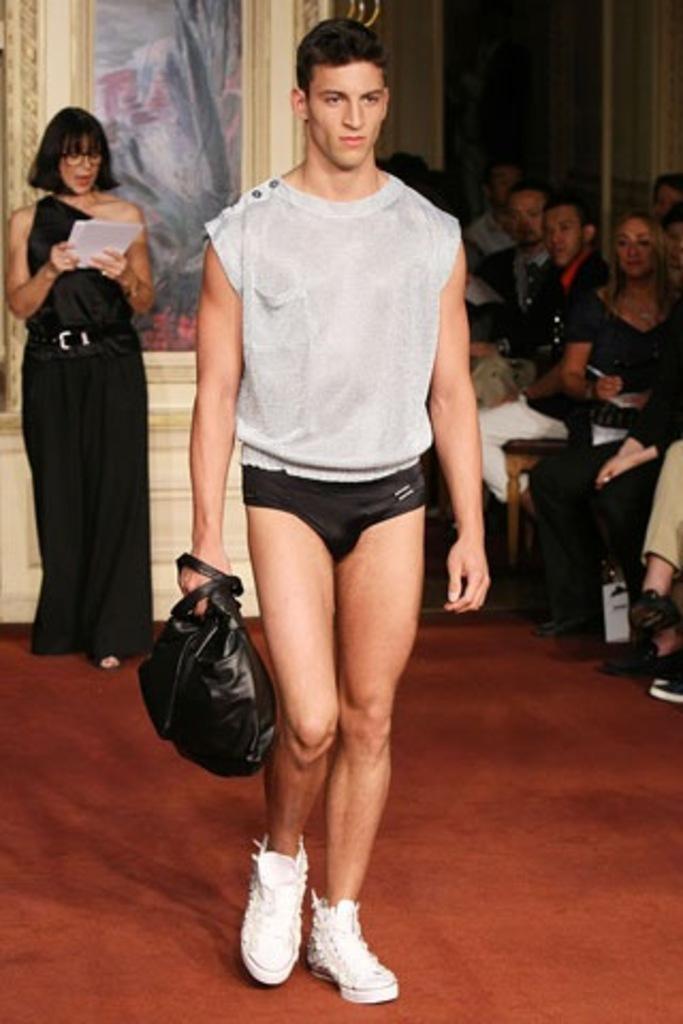In one or two sentences, can you explain what this image depicts? In this image there is a person holding a bag and he is standing. At the back there is a woman with black dress, she holding paper and at the right side of the image there is a group of people. At the back there is a frame on the wall. 